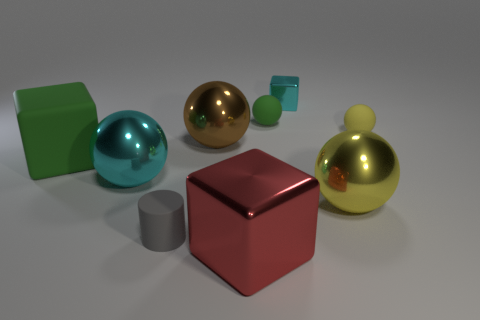Subtract all cyan balls. How many balls are left? 4 Subtract all cyan balls. How many balls are left? 4 Subtract all blue spheres. Subtract all gray cubes. How many spheres are left? 5 Add 1 large yellow matte blocks. How many objects exist? 10 Subtract all cylinders. How many objects are left? 8 Subtract all red blocks. Subtract all large things. How many objects are left? 3 Add 1 cylinders. How many cylinders are left? 2 Add 3 large brown spheres. How many large brown spheres exist? 4 Subtract 1 brown balls. How many objects are left? 8 